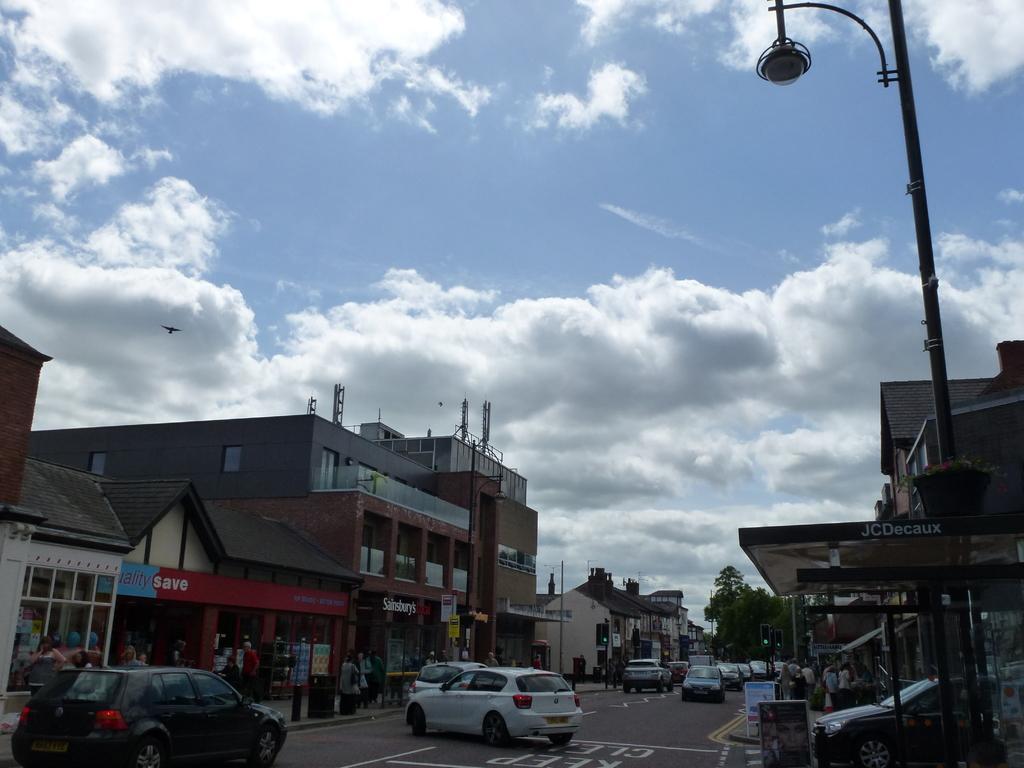Describe this image in one or two sentences. In this image I can see few cars which are black and white in color on the road and I can see few persons standing on the side walk and in the background I can see few buildings, few vehicles on the road, few poles, a street light, few trees, a bird and the sky in the background. 